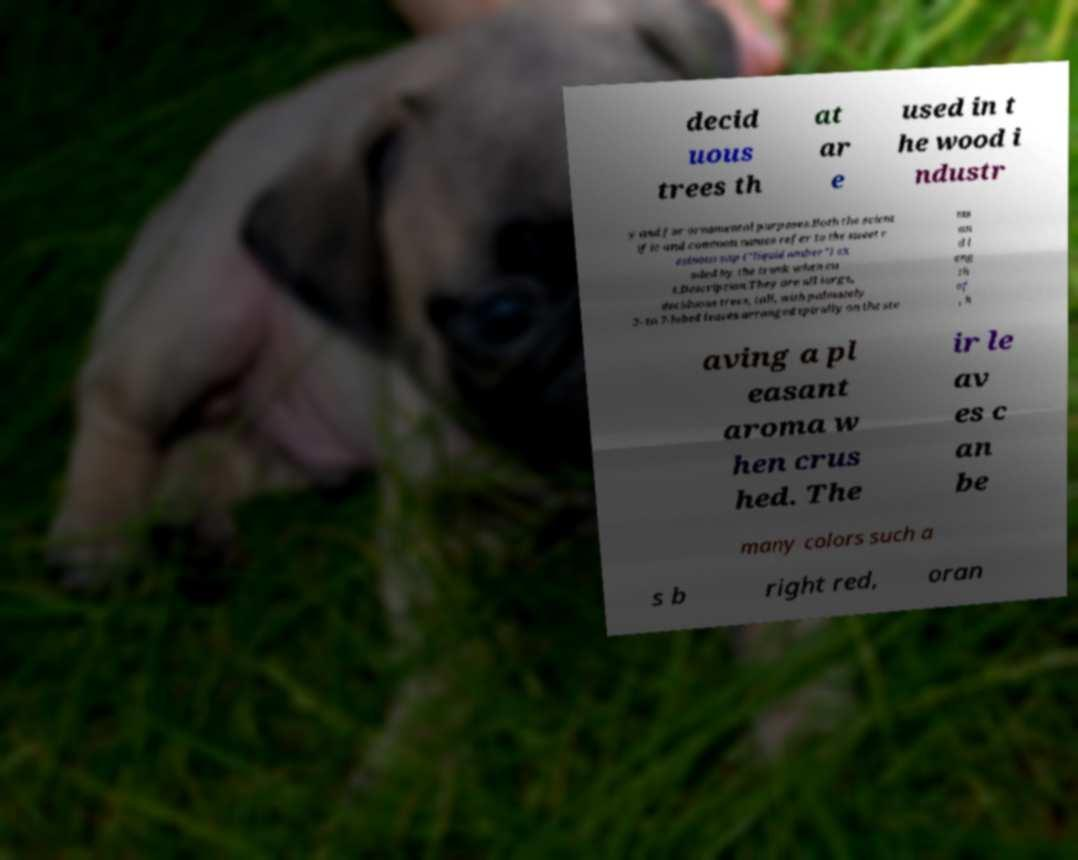For documentation purposes, I need the text within this image transcribed. Could you provide that? decid uous trees th at ar e used in t he wood i ndustr y and for ornamental purposes.Both the scient ific and common names refer to the sweet r esinous sap ("liquid amber") ex uded by the trunk when cu t.Description.They are all large, deciduous trees, tall, with palmately 3- to 7-lobed leaves arranged spirally on the ste ms an d l eng th of , h aving a pl easant aroma w hen crus hed. The ir le av es c an be many colors such a s b right red, oran 